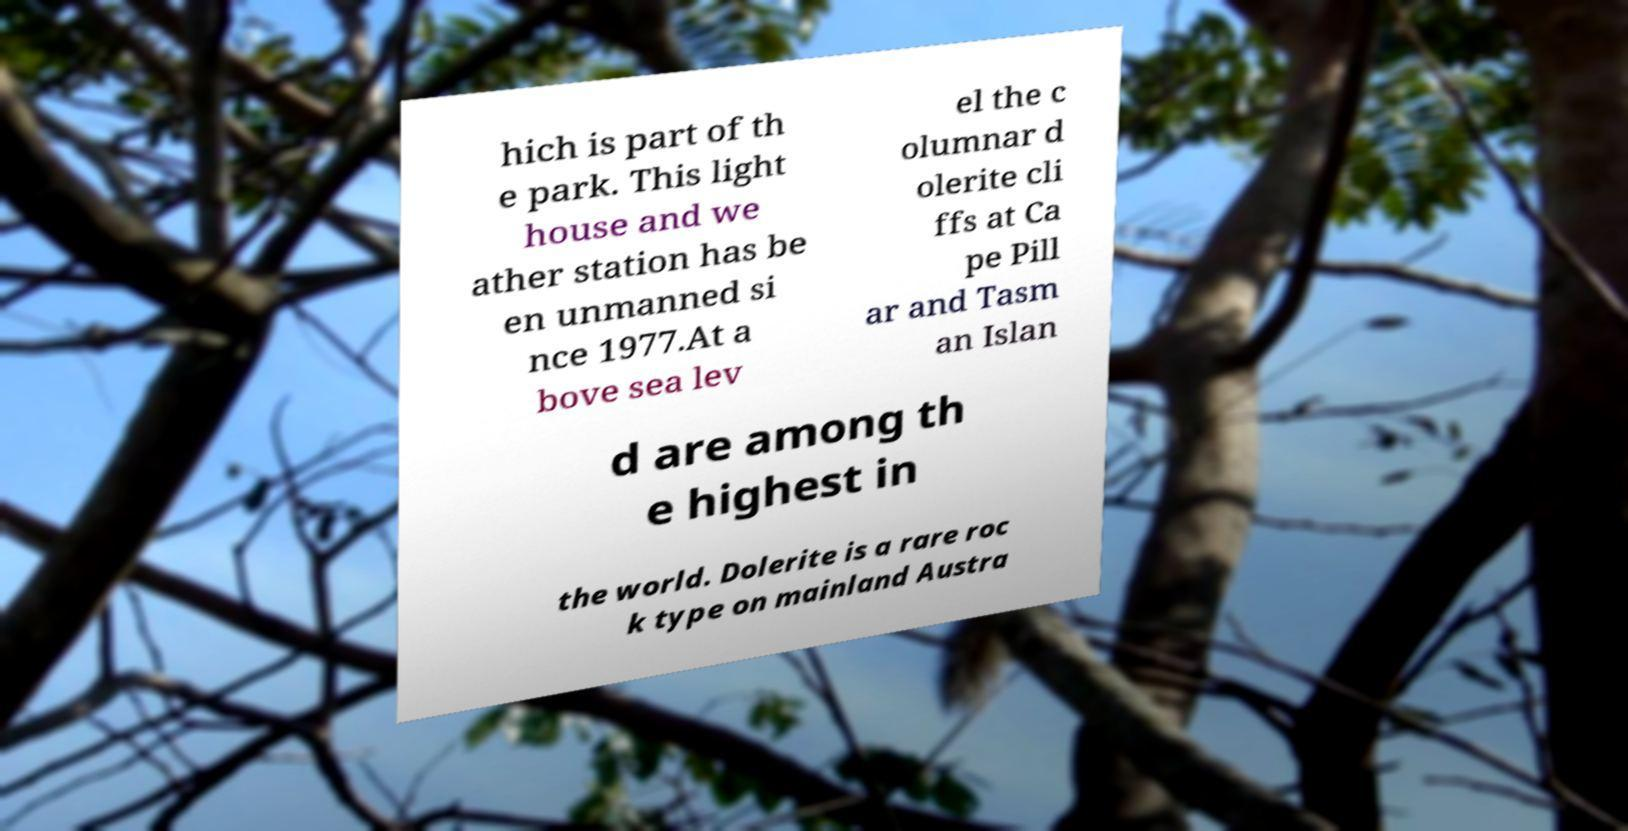Could you assist in decoding the text presented in this image and type it out clearly? hich is part of th e park. This light house and we ather station has be en unmanned si nce 1977.At a bove sea lev el the c olumnar d olerite cli ffs at Ca pe Pill ar and Tasm an Islan d are among th e highest in the world. Dolerite is a rare roc k type on mainland Austra 